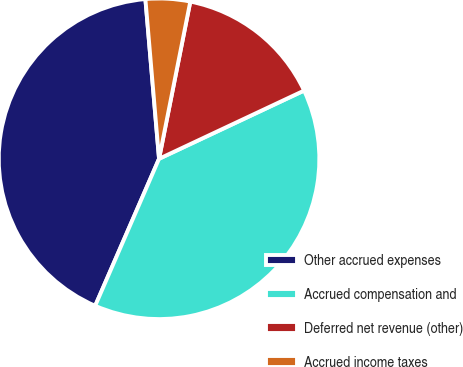Convert chart. <chart><loc_0><loc_0><loc_500><loc_500><pie_chart><fcel>Other accrued expenses<fcel>Accrued compensation and<fcel>Deferred net revenue (other)<fcel>Accrued income taxes<nl><fcel>42.12%<fcel>38.52%<fcel>14.88%<fcel>4.48%<nl></chart> 